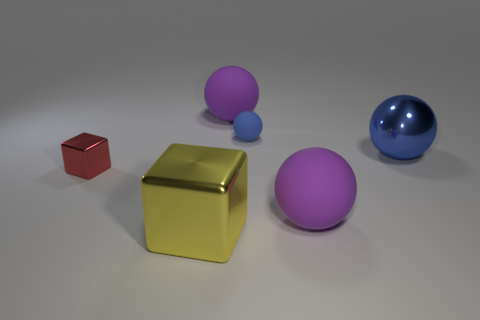Add 2 blocks. How many objects exist? 8 Subtract all cubes. How many objects are left? 4 Subtract all tiny blue objects. Subtract all purple balls. How many objects are left? 3 Add 4 big shiny blocks. How many big shiny blocks are left? 5 Add 5 big purple rubber things. How many big purple rubber things exist? 7 Subtract 1 red cubes. How many objects are left? 5 